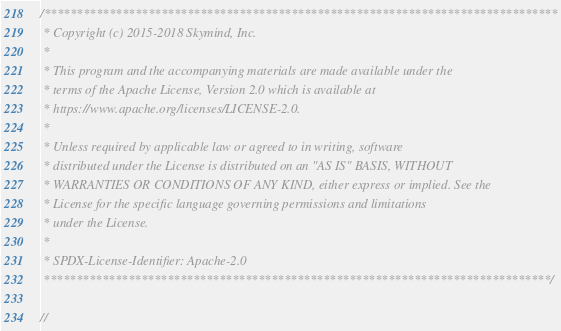Convert code to text. <code><loc_0><loc_0><loc_500><loc_500><_Cuda_>/*******************************************************************************
 * Copyright (c) 2015-2018 Skymind, Inc.
 *
 * This program and the accompanying materials are made available under the
 * terms of the Apache License, Version 2.0 which is available at
 * https://www.apache.org/licenses/LICENSE-2.0.
 *
 * Unless required by applicable law or agreed to in writing, software
 * distributed under the License is distributed on an "AS IS" BASIS, WITHOUT
 * WARRANTIES OR CONDITIONS OF ANY KIND, either express or implied. See the
 * License for the specific language governing permissions and limitations
 * under the License.
 *
 * SPDX-License-Identifier: Apache-2.0
 ******************************************************************************/

//</code> 